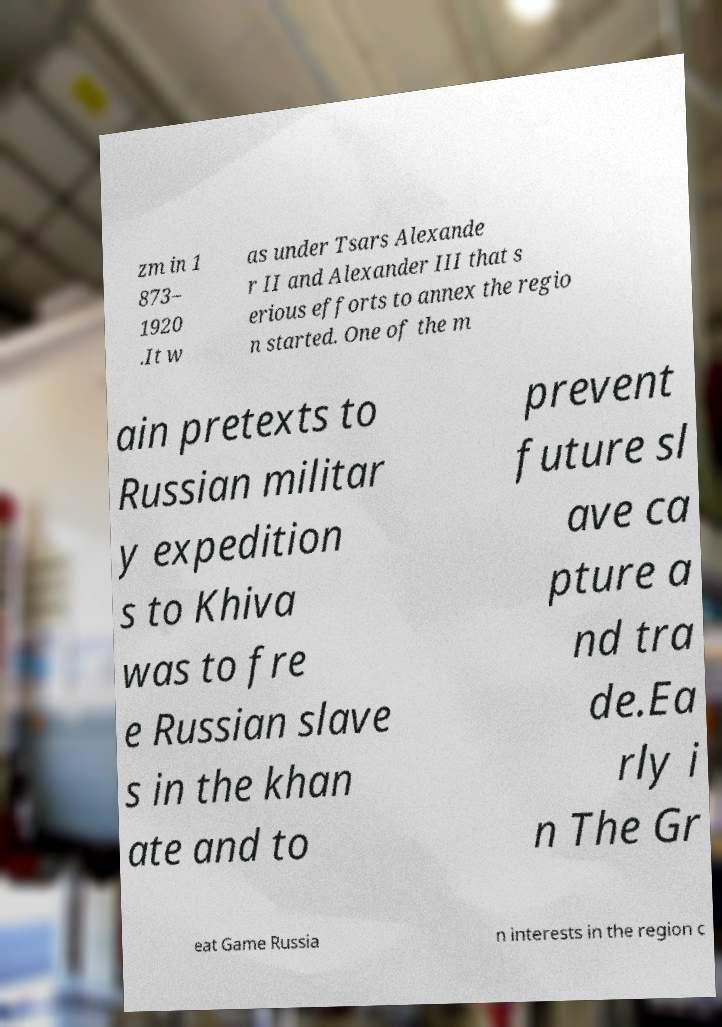Can you accurately transcribe the text from the provided image for me? zm in 1 873– 1920 .It w as under Tsars Alexande r II and Alexander III that s erious efforts to annex the regio n started. One of the m ain pretexts to Russian militar y expedition s to Khiva was to fre e Russian slave s in the khan ate and to prevent future sl ave ca pture a nd tra de.Ea rly i n The Gr eat Game Russia n interests in the region c 